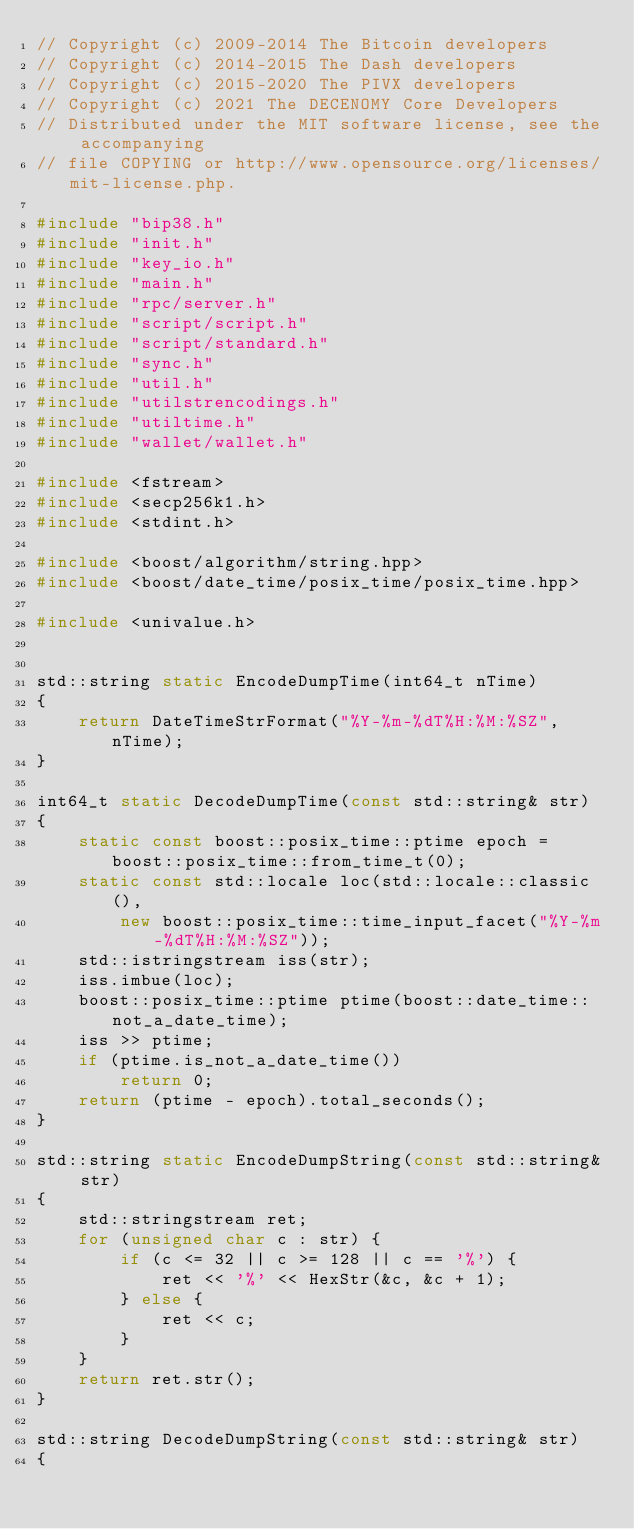<code> <loc_0><loc_0><loc_500><loc_500><_C++_>// Copyright (c) 2009-2014 The Bitcoin developers
// Copyright (c) 2014-2015 The Dash developers
// Copyright (c) 2015-2020 The PIVX developers
// Copyright (c) 2021 The DECENOMY Core Developers
// Distributed under the MIT software license, see the accompanying
// file COPYING or http://www.opensource.org/licenses/mit-license.php.

#include "bip38.h"
#include "init.h"
#include "key_io.h"
#include "main.h"
#include "rpc/server.h"
#include "script/script.h"
#include "script/standard.h"
#include "sync.h"
#include "util.h"
#include "utilstrencodings.h"
#include "utiltime.h"
#include "wallet/wallet.h"

#include <fstream>
#include <secp256k1.h>
#include <stdint.h>

#include <boost/algorithm/string.hpp>
#include <boost/date_time/posix_time/posix_time.hpp>

#include <univalue.h>


std::string static EncodeDumpTime(int64_t nTime)
{
    return DateTimeStrFormat("%Y-%m-%dT%H:%M:%SZ", nTime);
}

int64_t static DecodeDumpTime(const std::string& str)
{
    static const boost::posix_time::ptime epoch = boost::posix_time::from_time_t(0);
    static const std::locale loc(std::locale::classic(),
        new boost::posix_time::time_input_facet("%Y-%m-%dT%H:%M:%SZ"));
    std::istringstream iss(str);
    iss.imbue(loc);
    boost::posix_time::ptime ptime(boost::date_time::not_a_date_time);
    iss >> ptime;
    if (ptime.is_not_a_date_time())
        return 0;
    return (ptime - epoch).total_seconds();
}

std::string static EncodeDumpString(const std::string& str)
{
    std::stringstream ret;
    for (unsigned char c : str) {
        if (c <= 32 || c >= 128 || c == '%') {
            ret << '%' << HexStr(&c, &c + 1);
        } else {
            ret << c;
        }
    }
    return ret.str();
}

std::string DecodeDumpString(const std::string& str)
{</code> 